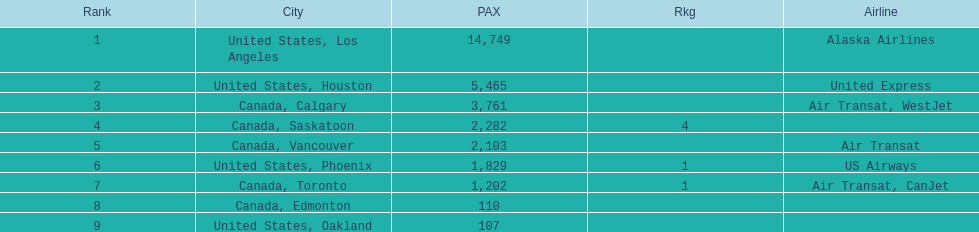What are all the cities? United States, Los Angeles, United States, Houston, Canada, Calgary, Canada, Saskatoon, Canada, Vancouver, United States, Phoenix, Canada, Toronto, Canada, Edmonton, United States, Oakland. How many passengers do they service? 14,749, 5,465, 3,761, 2,282, 2,103, 1,829, 1,202, 110, 107. Help me parse the entirety of this table. {'header': ['Rank', 'City', 'PAX', 'Rkg', 'Airline'], 'rows': [['1', 'United States, Los Angeles', '14,749', '', 'Alaska Airlines'], ['2', 'United States, Houston', '5,465', '', 'United Express'], ['3', 'Canada, Calgary', '3,761', '', 'Air Transat, WestJet'], ['4', 'Canada, Saskatoon', '2,282', '4', ''], ['5', 'Canada, Vancouver', '2,103', '', 'Air Transat'], ['6', 'United States, Phoenix', '1,829', '1', 'US Airways'], ['7', 'Canada, Toronto', '1,202', '1', 'Air Transat, CanJet'], ['8', 'Canada, Edmonton', '110', '', ''], ['9', 'United States, Oakland', '107', '', '']]} Which city, when combined with los angeles, totals nearly 19,000? Canada, Calgary. 